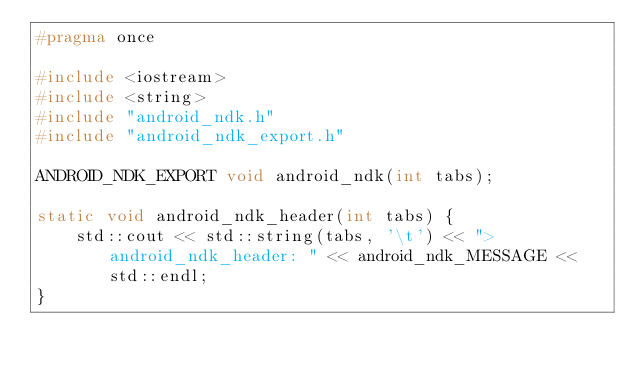Convert code to text. <code><loc_0><loc_0><loc_500><loc_500><_C_>#pragma once

#include <iostream>
#include <string>
#include "android_ndk.h"
#include "android_ndk_export.h"

ANDROID_NDK_EXPORT void android_ndk(int tabs);

static void android_ndk_header(int tabs) {
    std::cout << std::string(tabs, '\t') << "> android_ndk_header: " << android_ndk_MESSAGE << std::endl;
}</code> 